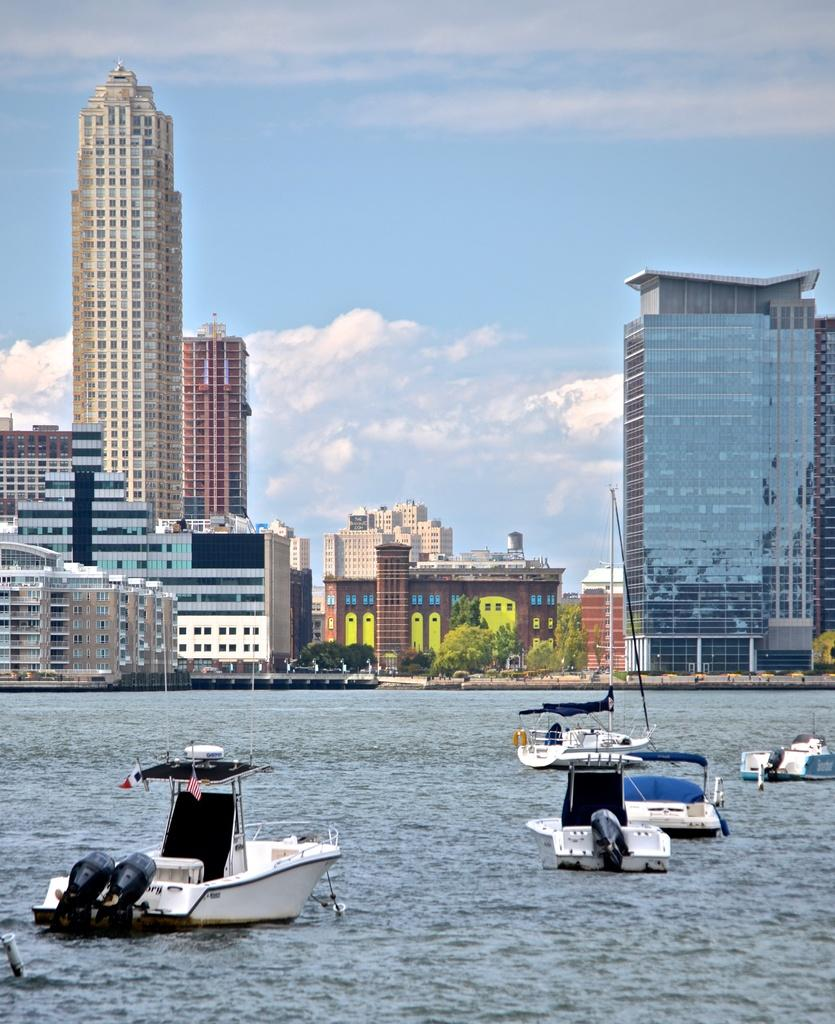What is the primary element in the image? There is water in the image. What is on the water in the image? There are boats on the water. What can be seen in the background of the image? There are buildings and trees in the background of the image. What is visible at the top of the image? The sky is visible at the top of the image. Who is the owner of the store in the image? There is no store present in the image, so it is not possible to determine the owner. 